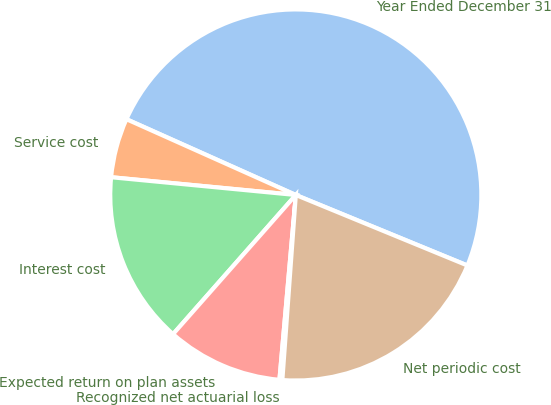<chart> <loc_0><loc_0><loc_500><loc_500><pie_chart><fcel>Year Ended December 31<fcel>Service cost<fcel>Interest cost<fcel>Expected return on plan assets<fcel>Recognized net actuarial loss<fcel>Net periodic cost<nl><fcel>49.51%<fcel>5.17%<fcel>15.02%<fcel>10.1%<fcel>0.25%<fcel>19.95%<nl></chart> 